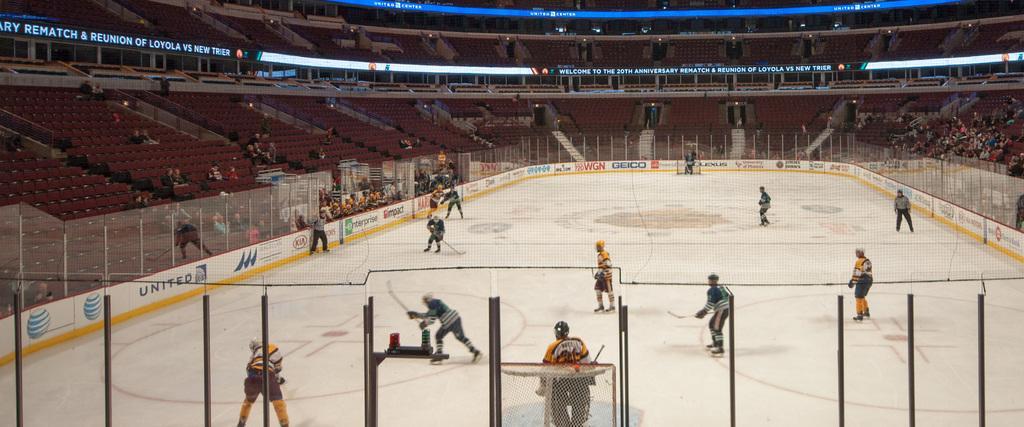In one or two sentences, can you explain what this image depicts? In this image there is a fence. Bottom of the image there is a net. Few persons are playing the game on the ground. They are holding the sticks. Background there are stairs. Few people are on the stairs. Few banners are attached to the fence which are in the balcony. 